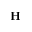<formula> <loc_0><loc_0><loc_500><loc_500>H</formula> 